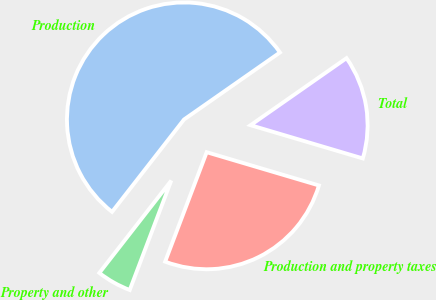Convert chart to OTSL. <chart><loc_0><loc_0><loc_500><loc_500><pie_chart><fcel>Production<fcel>Property and other<fcel>Production and property taxes<fcel>Total<nl><fcel>54.76%<fcel>4.76%<fcel>26.19%<fcel>14.29%<nl></chart> 